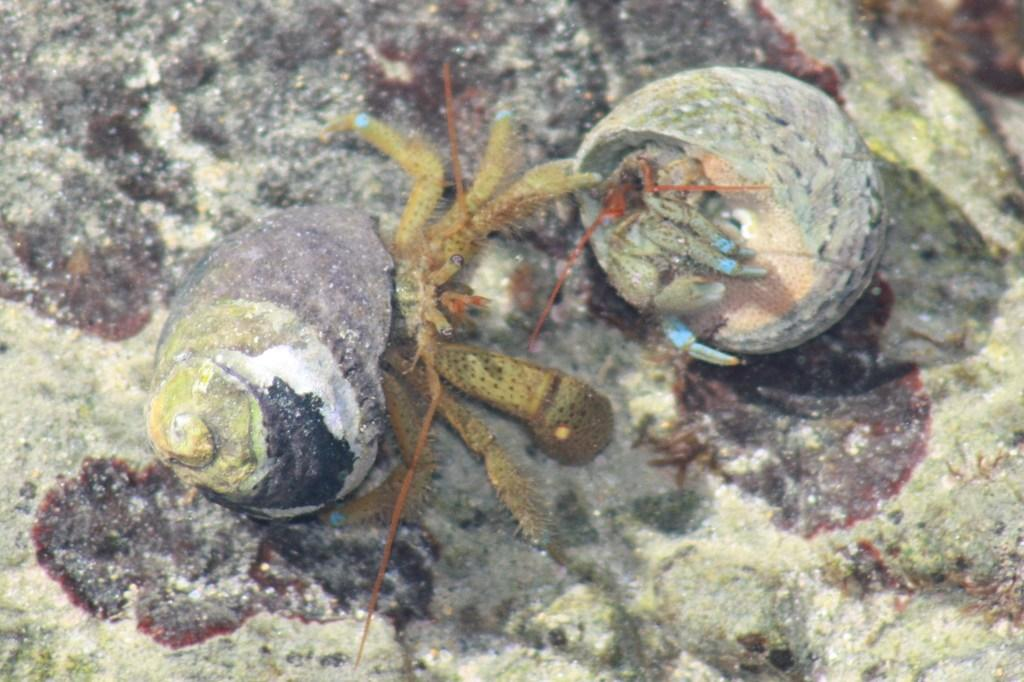What type of environment is shown in the image? The image depicts an underwater environment. What creatures can be seen in the image? There are pond snails in the middle of the image. What type of cheese is being used as a cushion for the pond snails in the image? There is no cheese or cushion present in the image; it depicts an underwater environment with pond snails. 